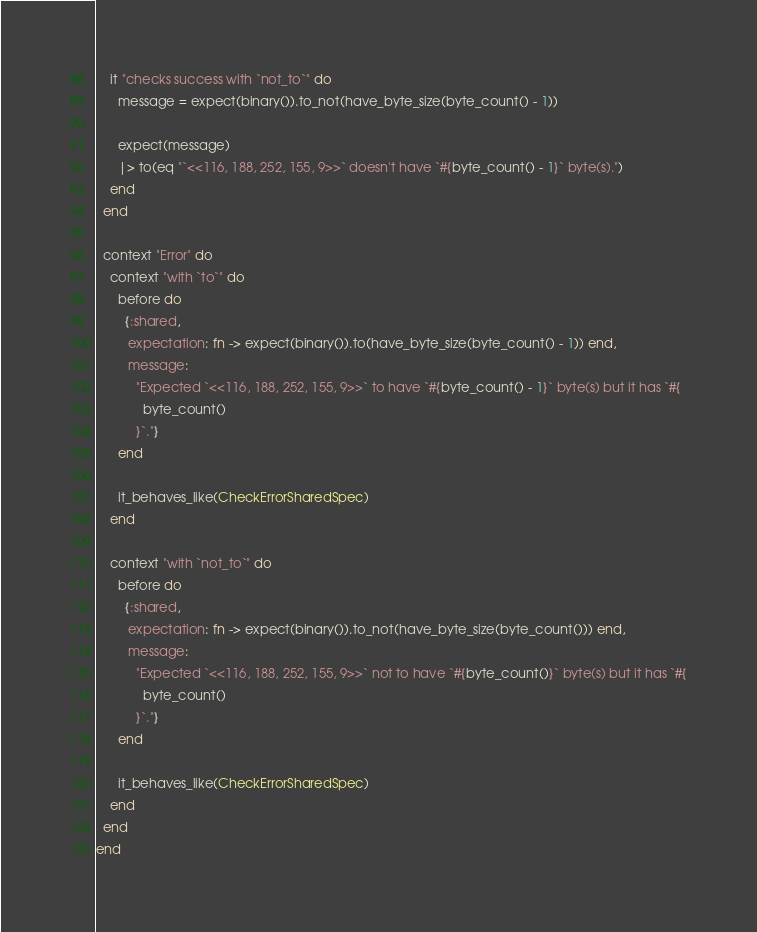Convert code to text. <code><loc_0><loc_0><loc_500><loc_500><_Elixir_>    it "checks success with `not_to`" do
      message = expect(binary()).to_not(have_byte_size(byte_count() - 1))

      expect(message)
      |> to(eq "`<<116, 188, 252, 155, 9>>` doesn't have `#{byte_count() - 1}` byte(s).")
    end
  end

  context "Error" do
    context "with `to`" do
      before do
        {:shared,
         expectation: fn -> expect(binary()).to(have_byte_size(byte_count() - 1)) end,
         message:
           "Expected `<<116, 188, 252, 155, 9>>` to have `#{byte_count() - 1}` byte(s) but it has `#{
             byte_count()
           }`."}
      end

      it_behaves_like(CheckErrorSharedSpec)
    end

    context "with `not_to`" do
      before do
        {:shared,
         expectation: fn -> expect(binary()).to_not(have_byte_size(byte_count())) end,
         message:
           "Expected `<<116, 188, 252, 155, 9>>` not to have `#{byte_count()}` byte(s) but it has `#{
             byte_count()
           }`."}
      end

      it_behaves_like(CheckErrorSharedSpec)
    end
  end
end
</code> 